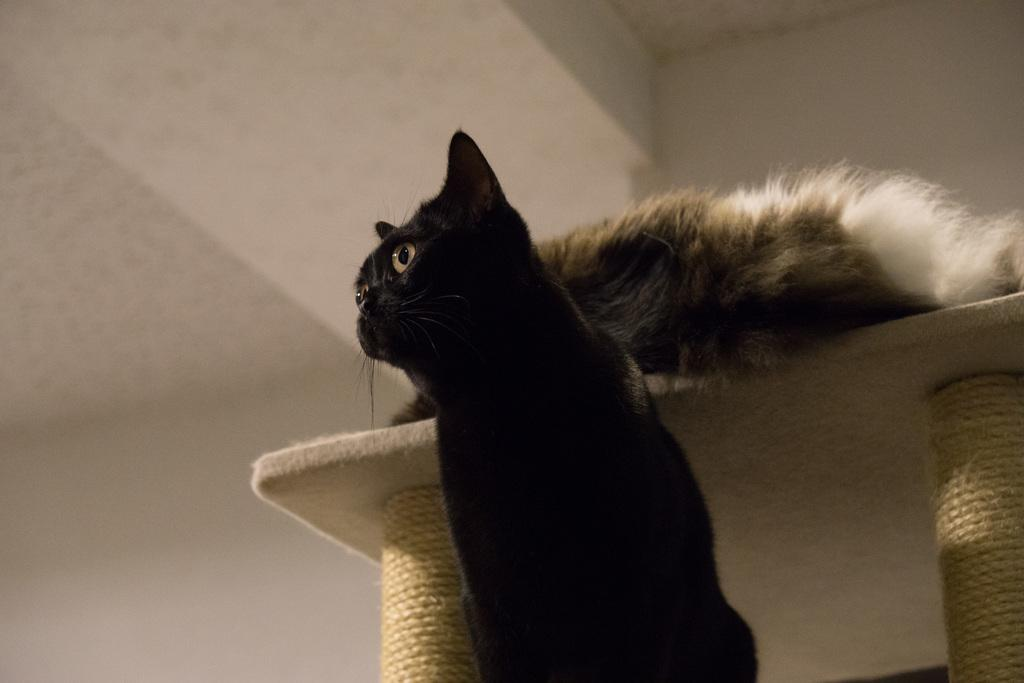What is the color of the wall in the image? There is a white color wall in the image. What furniture is present in the image? There is a table in the image. How many cats are in the image? There are two cats in the image. What is the color of one of the cats? One of the cats is black in color. How many pears are on the table in the image? There are no pears present in the image; the focus is on the cats and the table. Is the room in the image particularly quiet? The image does not provide any information about the noise level in the room, so we cannot determine if it is quiet or not. 